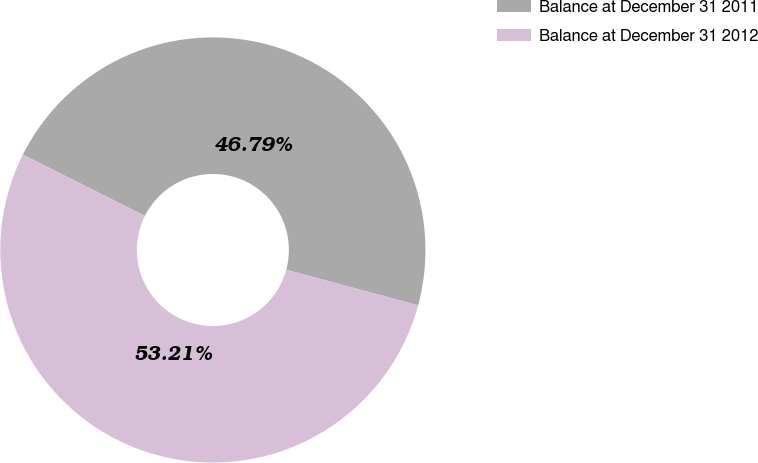Convert chart to OTSL. <chart><loc_0><loc_0><loc_500><loc_500><pie_chart><fcel>Balance at December 31 2011<fcel>Balance at December 31 2012<nl><fcel>46.79%<fcel>53.21%<nl></chart> 